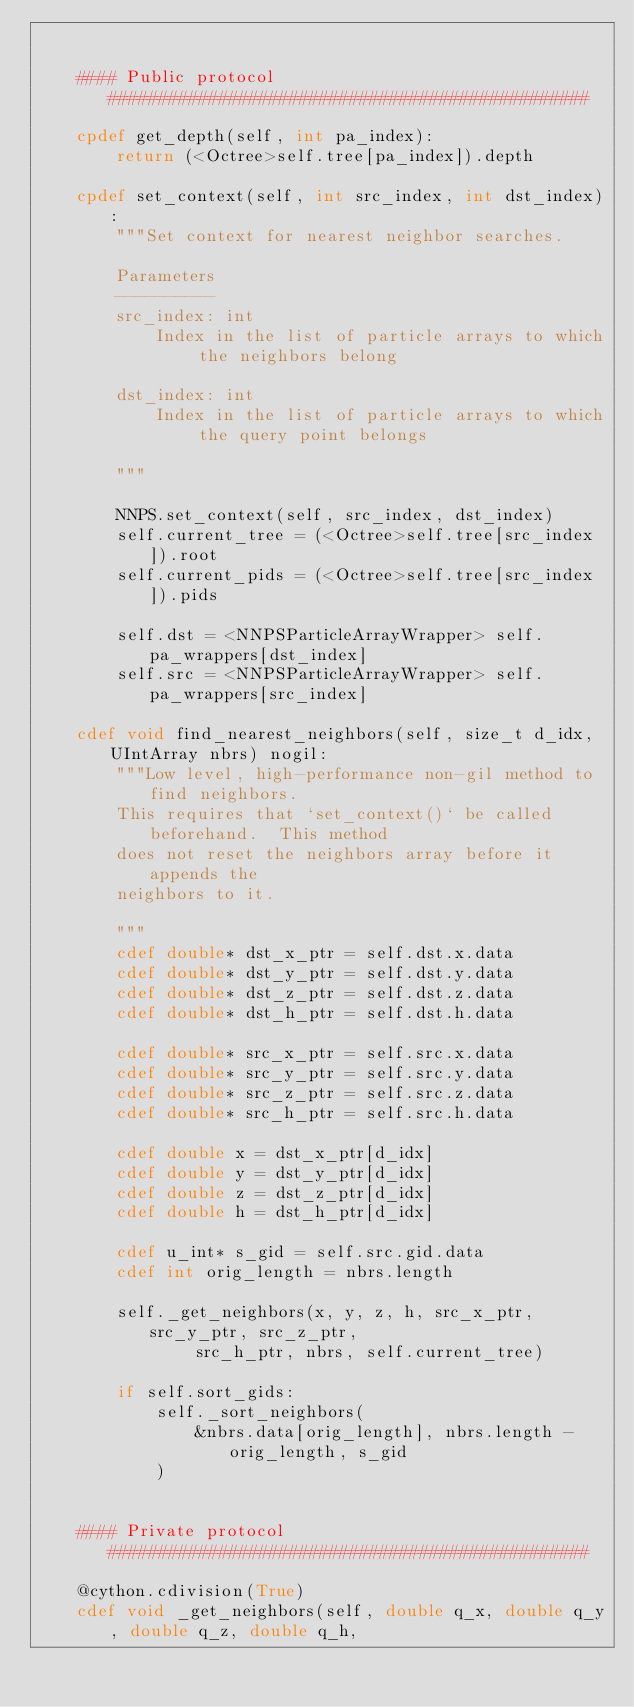<code> <loc_0><loc_0><loc_500><loc_500><_Cython_>

    #### Public protocol ################################################

    cpdef get_depth(self, int pa_index):
        return (<Octree>self.tree[pa_index]).depth

    cpdef set_context(self, int src_index, int dst_index):
        """Set context for nearest neighbor searches.

        Parameters
        ----------
        src_index: int
            Index in the list of particle arrays to which the neighbors belong

        dst_index: int
            Index in the list of particle arrays to which the query point belongs

        """

        NNPS.set_context(self, src_index, dst_index)
        self.current_tree = (<Octree>self.tree[src_index]).root
        self.current_pids = (<Octree>self.tree[src_index]).pids

        self.dst = <NNPSParticleArrayWrapper> self.pa_wrappers[dst_index]
        self.src = <NNPSParticleArrayWrapper> self.pa_wrappers[src_index]

    cdef void find_nearest_neighbors(self, size_t d_idx, UIntArray nbrs) nogil:
        """Low level, high-performance non-gil method to find neighbors.
        This requires that `set_context()` be called beforehand.  This method
        does not reset the neighbors array before it appends the
        neighbors to it.

        """
        cdef double* dst_x_ptr = self.dst.x.data
        cdef double* dst_y_ptr = self.dst.y.data
        cdef double* dst_z_ptr = self.dst.z.data
        cdef double* dst_h_ptr = self.dst.h.data

        cdef double* src_x_ptr = self.src.x.data
        cdef double* src_y_ptr = self.src.y.data
        cdef double* src_z_ptr = self.src.z.data
        cdef double* src_h_ptr = self.src.h.data

        cdef double x = dst_x_ptr[d_idx]
        cdef double y = dst_y_ptr[d_idx]
        cdef double z = dst_z_ptr[d_idx]
        cdef double h = dst_h_ptr[d_idx]

        cdef u_int* s_gid = self.src.gid.data
        cdef int orig_length = nbrs.length

        self._get_neighbors(x, y, z, h, src_x_ptr, src_y_ptr, src_z_ptr,
                src_h_ptr, nbrs, self.current_tree)

        if self.sort_gids:
            self._sort_neighbors(
                &nbrs.data[orig_length], nbrs.length - orig_length, s_gid
            )


    #### Private protocol ################################################

    @cython.cdivision(True)
    cdef void _get_neighbors(self, double q_x, double q_y, double q_z, double q_h,</code> 